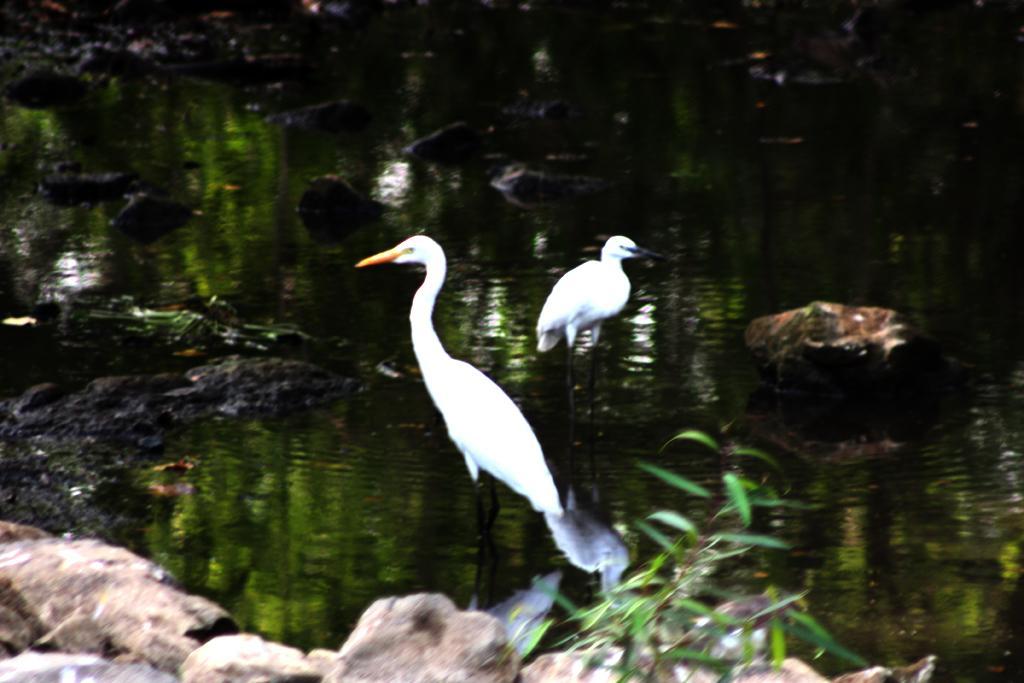Please provide a concise description of this image. There are two birds and we can see plant,stones and water. In the background it is blur. 